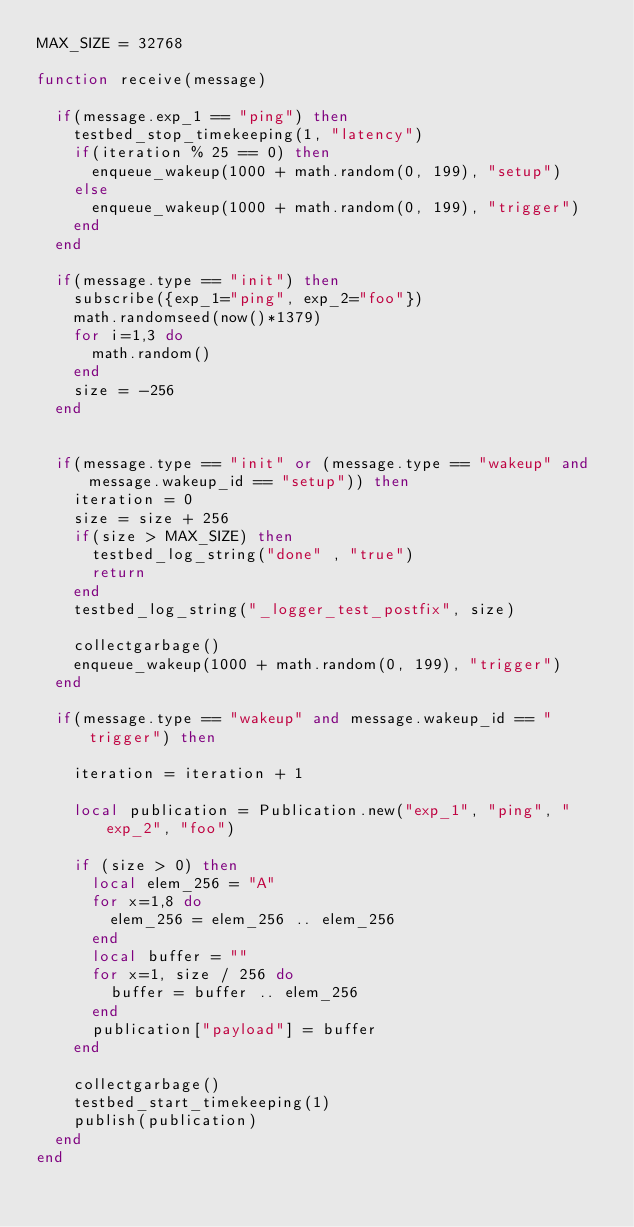<code> <loc_0><loc_0><loc_500><loc_500><_Lua_>MAX_SIZE = 32768

function receive(message)

  if(message.exp_1 == "ping") then
    testbed_stop_timekeeping(1, "latency")
    if(iteration % 25 == 0) then
      enqueue_wakeup(1000 + math.random(0, 199), "setup")
    else
      enqueue_wakeup(1000 + math.random(0, 199), "trigger")
    end
  end

  if(message.type == "init") then
    subscribe({exp_1="ping", exp_2="foo"})
    math.randomseed(now()*1379)
    for i=1,3 do
      math.random()
    end
    size = -256
  end


  if(message.type == "init" or (message.type == "wakeup" and message.wakeup_id == "setup")) then
    iteration = 0
    size = size + 256
    if(size > MAX_SIZE) then
      testbed_log_string("done" , "true")
      return
    end
    testbed_log_string("_logger_test_postfix", size)

    collectgarbage()
    enqueue_wakeup(1000 + math.random(0, 199), "trigger")
  end

  if(message.type == "wakeup" and message.wakeup_id == "trigger") then
    
    iteration = iteration + 1

    local publication = Publication.new("exp_1", "ping", "exp_2", "foo")
  
    if (size > 0) then
      local elem_256 = "A"
      for x=1,8 do
        elem_256 = elem_256 .. elem_256
      end
      local buffer = ""
      for x=1, size / 256 do
        buffer = buffer .. elem_256
      end
      publication["payload"] = buffer
    end

    collectgarbage()
    testbed_start_timekeeping(1)
    publish(publication)
  end
end</code> 